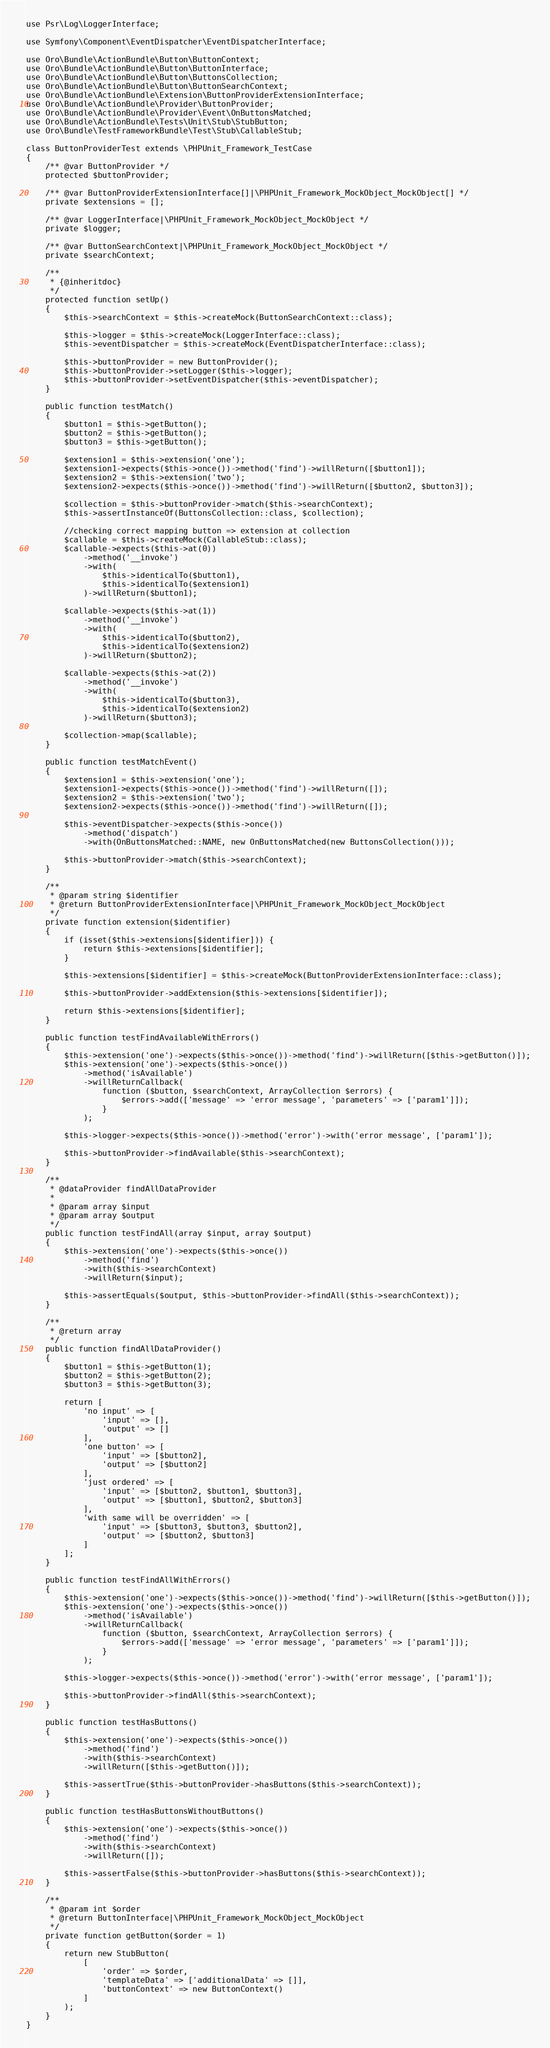Convert code to text. <code><loc_0><loc_0><loc_500><loc_500><_PHP_>use Psr\Log\LoggerInterface;

use Symfony\Component\EventDispatcher\EventDispatcherInterface;

use Oro\Bundle\ActionBundle\Button\ButtonContext;
use Oro\Bundle\ActionBundle\Button\ButtonInterface;
use Oro\Bundle\ActionBundle\Button\ButtonsCollection;
use Oro\Bundle\ActionBundle\Button\ButtonSearchContext;
use Oro\Bundle\ActionBundle\Extension\ButtonProviderExtensionInterface;
use Oro\Bundle\ActionBundle\Provider\ButtonProvider;
use Oro\Bundle\ActionBundle\Provider\Event\OnButtonsMatched;
use Oro\Bundle\ActionBundle\Tests\Unit\Stub\StubButton;
use Oro\Bundle\TestFrameworkBundle\Test\Stub\CallableStub;

class ButtonProviderTest extends \PHPUnit_Framework_TestCase
{
    /** @var ButtonProvider */
    protected $buttonProvider;

    /** @var ButtonProviderExtensionInterface[]|\PHPUnit_Framework_MockObject_MockObject[] */
    private $extensions = [];

    /** @var LoggerInterface|\PHPUnit_Framework_MockObject_MockObject */
    private $logger;

    /** @var ButtonSearchContext|\PHPUnit_Framework_MockObject_MockObject */
    private $searchContext;

    /**
     * {@inheritdoc}
     */
    protected function setUp()
    {
        $this->searchContext = $this->createMock(ButtonSearchContext::class);

        $this->logger = $this->createMock(LoggerInterface::class);
        $this->eventDispatcher = $this->createMock(EventDispatcherInterface::class);

        $this->buttonProvider = new ButtonProvider();
        $this->buttonProvider->setLogger($this->logger);
        $this->buttonProvider->setEventDispatcher($this->eventDispatcher);
    }

    public function testMatch()
    {
        $button1 = $this->getButton();
        $button2 = $this->getButton();
        $button3 = $this->getButton();

        $extension1 = $this->extension('one');
        $extension1->expects($this->once())->method('find')->willReturn([$button1]);
        $extension2 = $this->extension('two');
        $extension2->expects($this->once())->method('find')->willReturn([$button2, $button3]);

        $collection = $this->buttonProvider->match($this->searchContext);
        $this->assertInstanceOf(ButtonsCollection::class, $collection);

        //checking correct mapping button => extension at collection
        $callable = $this->createMock(CallableStub::class);
        $callable->expects($this->at(0))
            ->method('__invoke')
            ->with(
                $this->identicalTo($button1),
                $this->identicalTo($extension1)
            )->willReturn($button1);

        $callable->expects($this->at(1))
            ->method('__invoke')
            ->with(
                $this->identicalTo($button2),
                $this->identicalTo($extension2)
            )->willReturn($button2);

        $callable->expects($this->at(2))
            ->method('__invoke')
            ->with(
                $this->identicalTo($button3),
                $this->identicalTo($extension2)
            )->willReturn($button3);

        $collection->map($callable);
    }

    public function testMatchEvent()
    {
        $extension1 = $this->extension('one');
        $extension1->expects($this->once())->method('find')->willReturn([]);
        $extension2 = $this->extension('two');
        $extension2->expects($this->once())->method('find')->willReturn([]);

        $this->eventDispatcher->expects($this->once())
            ->method('dispatch')
            ->with(OnButtonsMatched::NAME, new OnButtonsMatched(new ButtonsCollection()));

        $this->buttonProvider->match($this->searchContext);
    }

    /**
     * @param string $identifier
     * @return ButtonProviderExtensionInterface|\PHPUnit_Framework_MockObject_MockObject
     */
    private function extension($identifier)
    {
        if (isset($this->extensions[$identifier])) {
            return $this->extensions[$identifier];
        }

        $this->extensions[$identifier] = $this->createMock(ButtonProviderExtensionInterface::class);

        $this->buttonProvider->addExtension($this->extensions[$identifier]);

        return $this->extensions[$identifier];
    }

    public function testFindAvailableWithErrors()
    {
        $this->extension('one')->expects($this->once())->method('find')->willReturn([$this->getButton()]);
        $this->extension('one')->expects($this->once())
            ->method('isAvailable')
            ->willReturnCallback(
                function ($button, $searchContext, ArrayCollection $errors) {
                    $errors->add(['message' => 'error message', 'parameters' => ['param1']]);
                }
            );

        $this->logger->expects($this->once())->method('error')->with('error message', ['param1']);

        $this->buttonProvider->findAvailable($this->searchContext);
    }

    /**
     * @dataProvider findAllDataProvider
     *
     * @param array $input
     * @param array $output
     */
    public function testFindAll(array $input, array $output)
    {
        $this->extension('one')->expects($this->once())
            ->method('find')
            ->with($this->searchContext)
            ->willReturn($input);

        $this->assertEquals($output, $this->buttonProvider->findAll($this->searchContext));
    }

    /**
     * @return array
     */
    public function findAllDataProvider()
    {
        $button1 = $this->getButton(1);
        $button2 = $this->getButton(2);
        $button3 = $this->getButton(3);

        return [
            'no input' => [
                'input' => [],
                'output' => []
            ],
            'one button' => [
                'input' => [$button2],
                'output' => [$button2]
            ],
            'just ordered' => [
                'input' => [$button2, $button1, $button3],
                'output' => [$button1, $button2, $button3]
            ],
            'with same will be overridden' => [
                'input' => [$button3, $button3, $button2],
                'output' => [$button2, $button3]
            ]
        ];
    }

    public function testFindAllWithErrors()
    {
        $this->extension('one')->expects($this->once())->method('find')->willReturn([$this->getButton()]);
        $this->extension('one')->expects($this->once())
            ->method('isAvailable')
            ->willReturnCallback(
                function ($button, $searchContext, ArrayCollection $errors) {
                    $errors->add(['message' => 'error message', 'parameters' => ['param1']]);
                }
            );

        $this->logger->expects($this->once())->method('error')->with('error message', ['param1']);

        $this->buttonProvider->findAll($this->searchContext);
    }

    public function testHasButtons()
    {
        $this->extension('one')->expects($this->once())
            ->method('find')
            ->with($this->searchContext)
            ->willReturn([$this->getButton()]);

        $this->assertTrue($this->buttonProvider->hasButtons($this->searchContext));
    }

    public function testHasButtonsWithoutButtons()
    {
        $this->extension('one')->expects($this->once())
            ->method('find')
            ->with($this->searchContext)
            ->willReturn([]);

        $this->assertFalse($this->buttonProvider->hasButtons($this->searchContext));
    }

    /**
     * @param int $order
     * @return ButtonInterface|\PHPUnit_Framework_MockObject_MockObject
     */
    private function getButton($order = 1)
    {
        return new StubButton(
            [
                'order' => $order,
                'templateData' => ['additionalData' => []],
                'buttonContext' => new ButtonContext()
            ]
        );
    }
}
</code> 